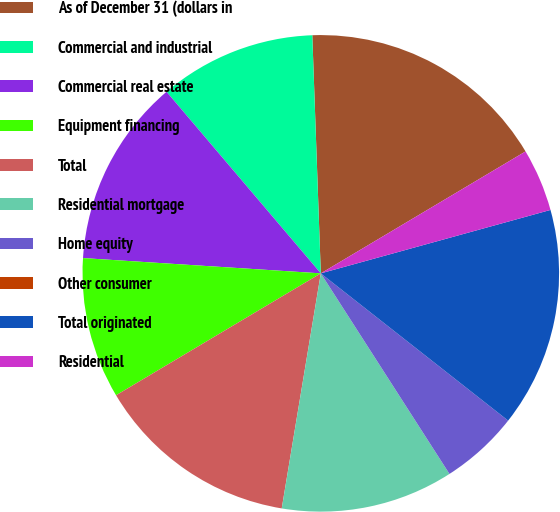Convert chart. <chart><loc_0><loc_0><loc_500><loc_500><pie_chart><fcel>As of December 31 (dollars in<fcel>Commercial and industrial<fcel>Commercial real estate<fcel>Equipment financing<fcel>Total<fcel>Residential mortgage<fcel>Home equity<fcel>Other consumer<fcel>Total originated<fcel>Residential<nl><fcel>17.02%<fcel>10.64%<fcel>12.77%<fcel>9.57%<fcel>13.83%<fcel>11.7%<fcel>5.32%<fcel>0.0%<fcel>14.89%<fcel>4.26%<nl></chart> 